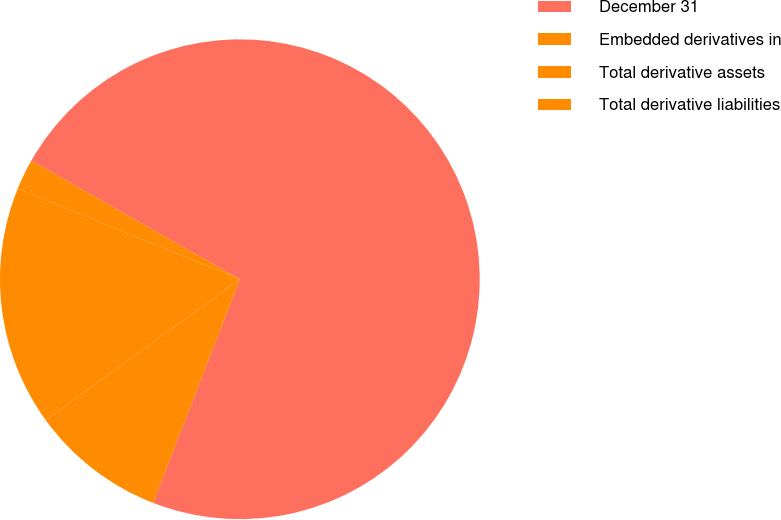Convert chart to OTSL. <chart><loc_0><loc_0><loc_500><loc_500><pie_chart><fcel>December 31<fcel>Embedded derivatives in<fcel>Total derivative assets<fcel>Total derivative liabilities<nl><fcel>72.66%<fcel>9.11%<fcel>16.17%<fcel>2.05%<nl></chart> 